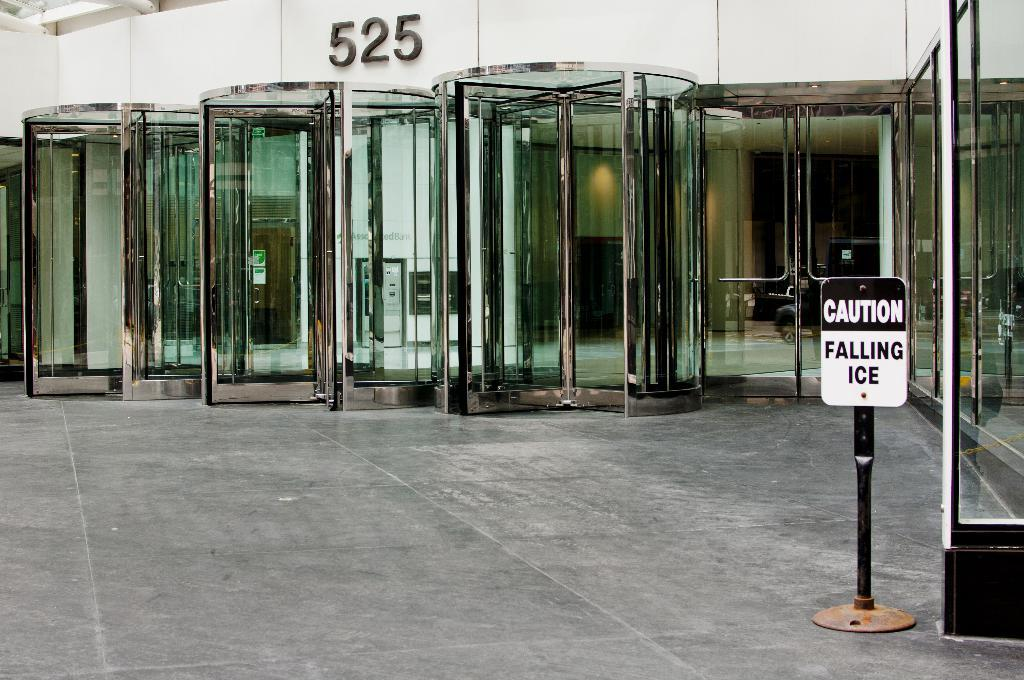What type of structure can be seen in the image? There is a building in the image. What part of the building is visible in the image? The floor is visible in the image. Is there any information or direction provided in the image? Yes, there is a sign board in the image. What are the walls made of in the image? The walls are present in the image, but the material is not specified. Can you see the friend of the person standing next to the building in the image? There is no person or friend visible in the image; it only shows the building, floor, sign board, and walls. 